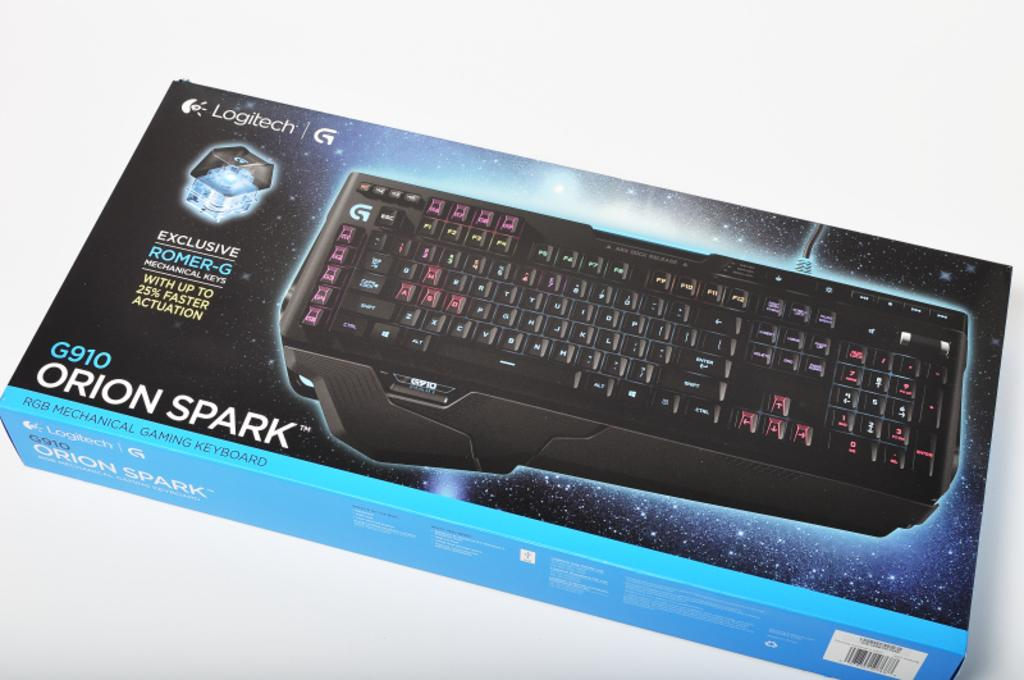<image>
Describe the image concisely. The orion spark keyboard is made by Logitech. 